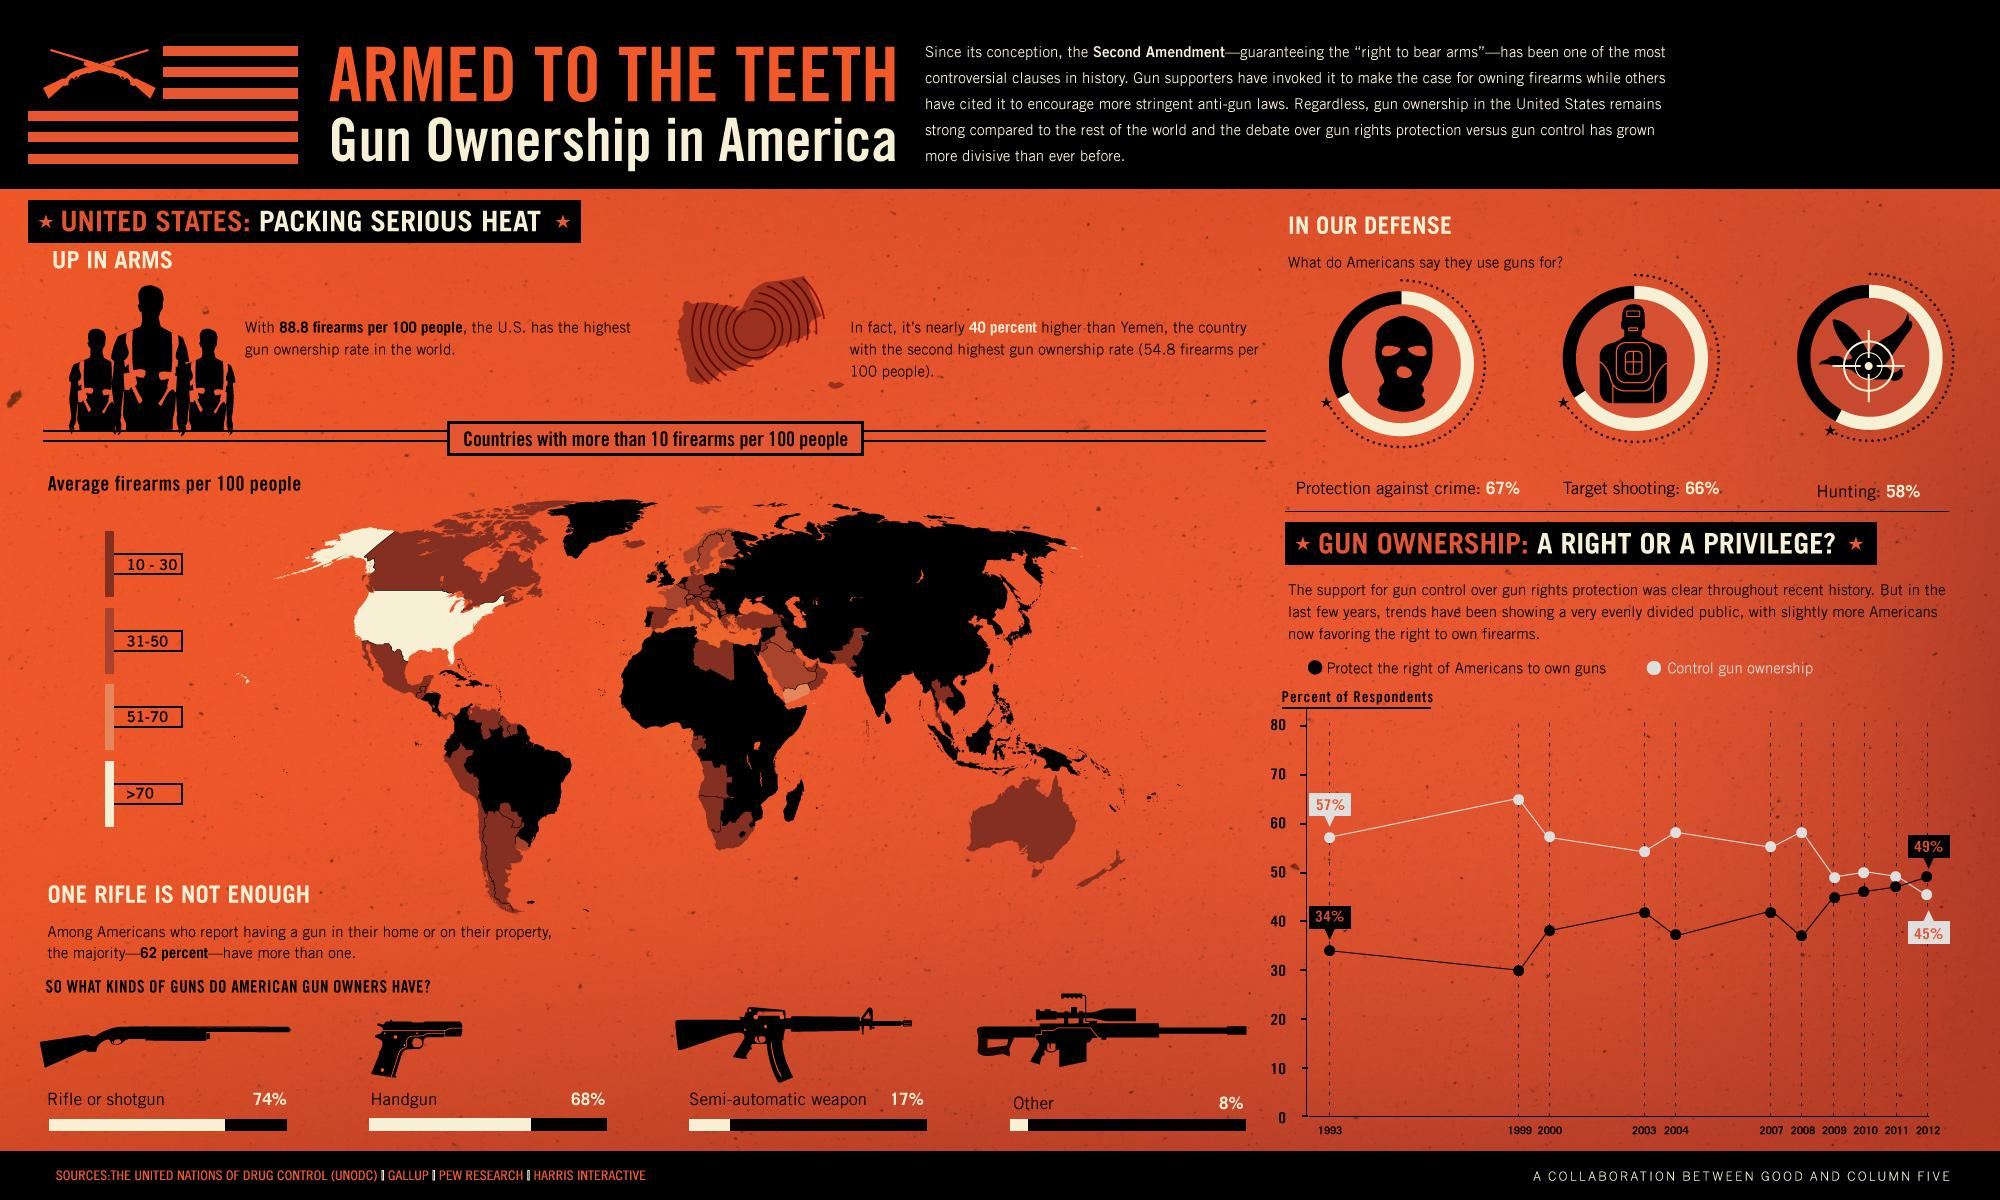Identify some key points in this picture. The overwhelming majority of American gun owners prefer to use rifles or shotguns, with rifles being the most commonly owned and most frequently used firearms among gun owners. In 2012, 45% of respondents supported stricter gun control laws. According to a recent survey, a significant portion of Americans, approximately 34%, do not use guns for target shooting. The United States has the highest gun ownership rate in the world. According to recent statistics, the gun ownership rate in the United States is approximately 88.8 firearms per 100 people. 